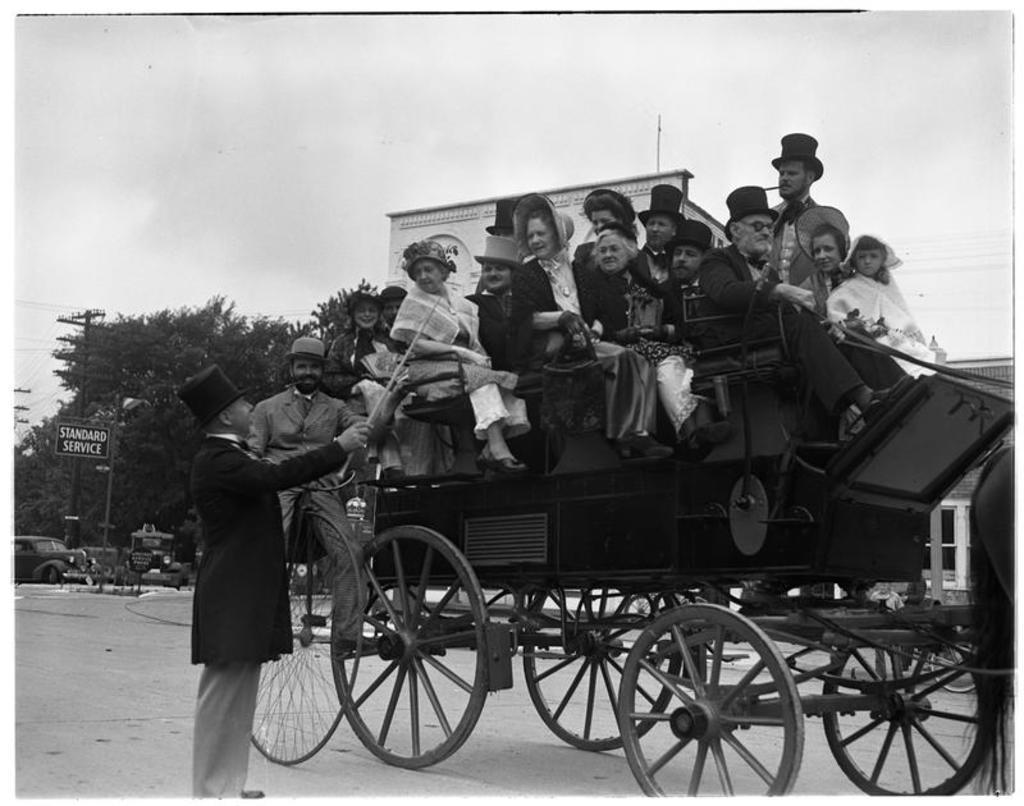Could you give a brief overview of what you see in this image? In this image we can see a few people, some of them are sitting on the cart, one person is standing on the road, he is holding a stick, there is a board with text on it, there are electric poles, trees, there is a house, vehicles, also we can see some part of an animal, and the sky. 